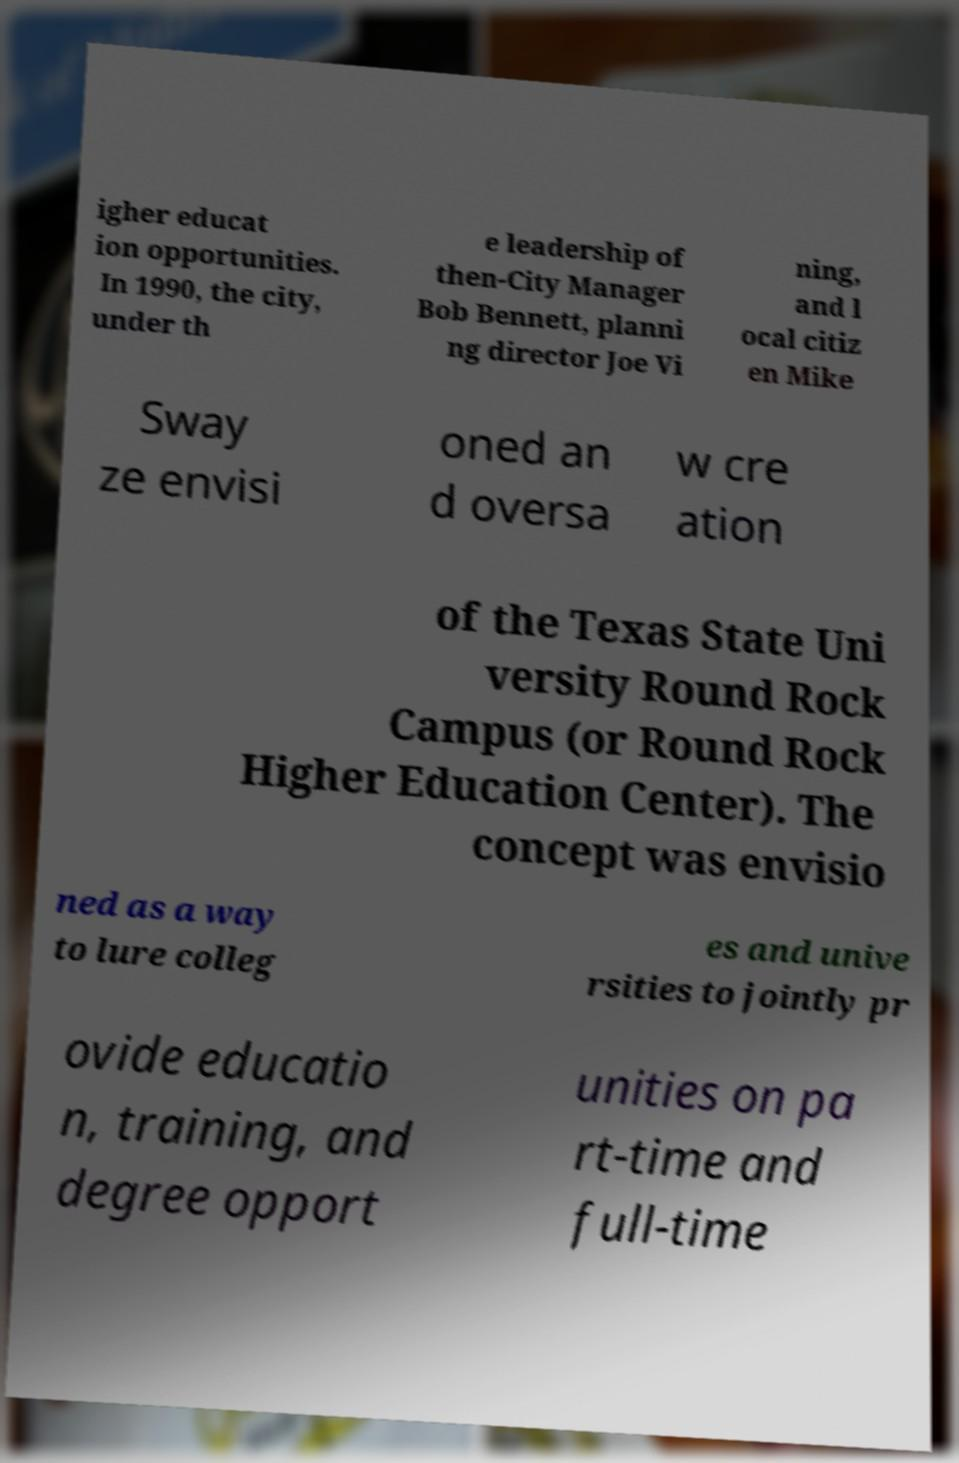Please read and relay the text visible in this image. What does it say? igher educat ion opportunities. In 1990, the city, under th e leadership of then-City Manager Bob Bennett, planni ng director Joe Vi ning, and l ocal citiz en Mike Sway ze envisi oned an d oversa w cre ation of the Texas State Uni versity Round Rock Campus (or Round Rock Higher Education Center). The concept was envisio ned as a way to lure colleg es and unive rsities to jointly pr ovide educatio n, training, and degree opport unities on pa rt-time and full-time 